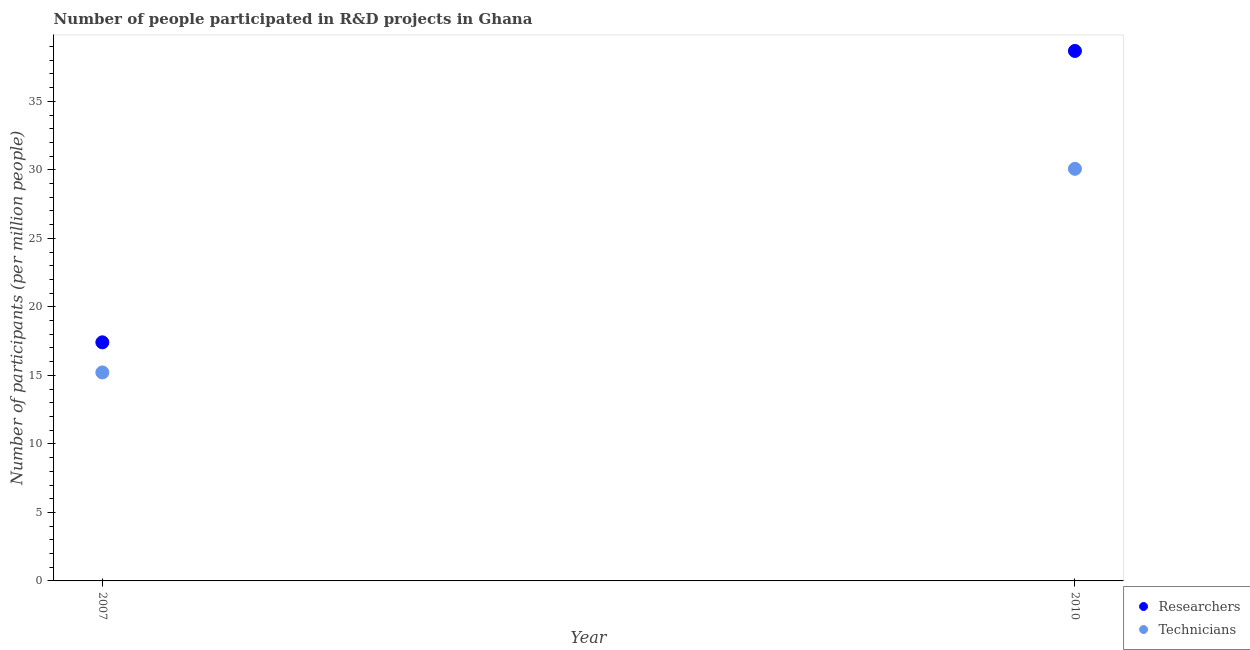Is the number of dotlines equal to the number of legend labels?
Keep it short and to the point. Yes. What is the number of researchers in 2010?
Your answer should be very brief. 38.68. Across all years, what is the maximum number of technicians?
Your response must be concise. 30.08. Across all years, what is the minimum number of technicians?
Provide a short and direct response. 15.22. In which year was the number of technicians minimum?
Give a very brief answer. 2007. What is the total number of researchers in the graph?
Ensure brevity in your answer.  56.09. What is the difference between the number of researchers in 2007 and that in 2010?
Provide a succinct answer. -21.27. What is the difference between the number of researchers in 2007 and the number of technicians in 2010?
Ensure brevity in your answer.  -12.66. What is the average number of technicians per year?
Make the answer very short. 22.65. In the year 2010, what is the difference between the number of technicians and number of researchers?
Offer a very short reply. -8.6. What is the ratio of the number of technicians in 2007 to that in 2010?
Provide a short and direct response. 0.51. Does the number of technicians monotonically increase over the years?
Ensure brevity in your answer.  Yes. Is the number of technicians strictly less than the number of researchers over the years?
Provide a short and direct response. Yes. How many dotlines are there?
Offer a very short reply. 2. How many years are there in the graph?
Give a very brief answer. 2. Are the values on the major ticks of Y-axis written in scientific E-notation?
Offer a terse response. No. Does the graph contain grids?
Provide a succinct answer. No. Where does the legend appear in the graph?
Provide a short and direct response. Bottom right. How many legend labels are there?
Give a very brief answer. 2. What is the title of the graph?
Your answer should be compact. Number of people participated in R&D projects in Ghana. What is the label or title of the Y-axis?
Your answer should be compact. Number of participants (per million people). What is the Number of participants (per million people) of Researchers in 2007?
Give a very brief answer. 17.41. What is the Number of participants (per million people) of Technicians in 2007?
Provide a short and direct response. 15.22. What is the Number of participants (per million people) in Researchers in 2010?
Give a very brief answer. 38.68. What is the Number of participants (per million people) in Technicians in 2010?
Keep it short and to the point. 30.08. Across all years, what is the maximum Number of participants (per million people) in Researchers?
Your answer should be very brief. 38.68. Across all years, what is the maximum Number of participants (per million people) of Technicians?
Your response must be concise. 30.08. Across all years, what is the minimum Number of participants (per million people) in Researchers?
Ensure brevity in your answer.  17.41. Across all years, what is the minimum Number of participants (per million people) in Technicians?
Ensure brevity in your answer.  15.22. What is the total Number of participants (per million people) of Researchers in the graph?
Offer a very short reply. 56.09. What is the total Number of participants (per million people) in Technicians in the graph?
Provide a succinct answer. 45.29. What is the difference between the Number of participants (per million people) in Researchers in 2007 and that in 2010?
Provide a short and direct response. -21.27. What is the difference between the Number of participants (per million people) in Technicians in 2007 and that in 2010?
Your response must be concise. -14.86. What is the difference between the Number of participants (per million people) in Researchers in 2007 and the Number of participants (per million people) in Technicians in 2010?
Give a very brief answer. -12.66. What is the average Number of participants (per million people) in Researchers per year?
Your response must be concise. 28.05. What is the average Number of participants (per million people) of Technicians per year?
Offer a very short reply. 22.65. In the year 2007, what is the difference between the Number of participants (per million people) of Researchers and Number of participants (per million people) of Technicians?
Make the answer very short. 2.2. In the year 2010, what is the difference between the Number of participants (per million people) of Researchers and Number of participants (per million people) of Technicians?
Provide a succinct answer. 8.6. What is the ratio of the Number of participants (per million people) in Researchers in 2007 to that in 2010?
Provide a short and direct response. 0.45. What is the ratio of the Number of participants (per million people) in Technicians in 2007 to that in 2010?
Your response must be concise. 0.51. What is the difference between the highest and the second highest Number of participants (per million people) in Researchers?
Your response must be concise. 21.27. What is the difference between the highest and the second highest Number of participants (per million people) in Technicians?
Your answer should be compact. 14.86. What is the difference between the highest and the lowest Number of participants (per million people) of Researchers?
Offer a terse response. 21.27. What is the difference between the highest and the lowest Number of participants (per million people) of Technicians?
Your response must be concise. 14.86. 